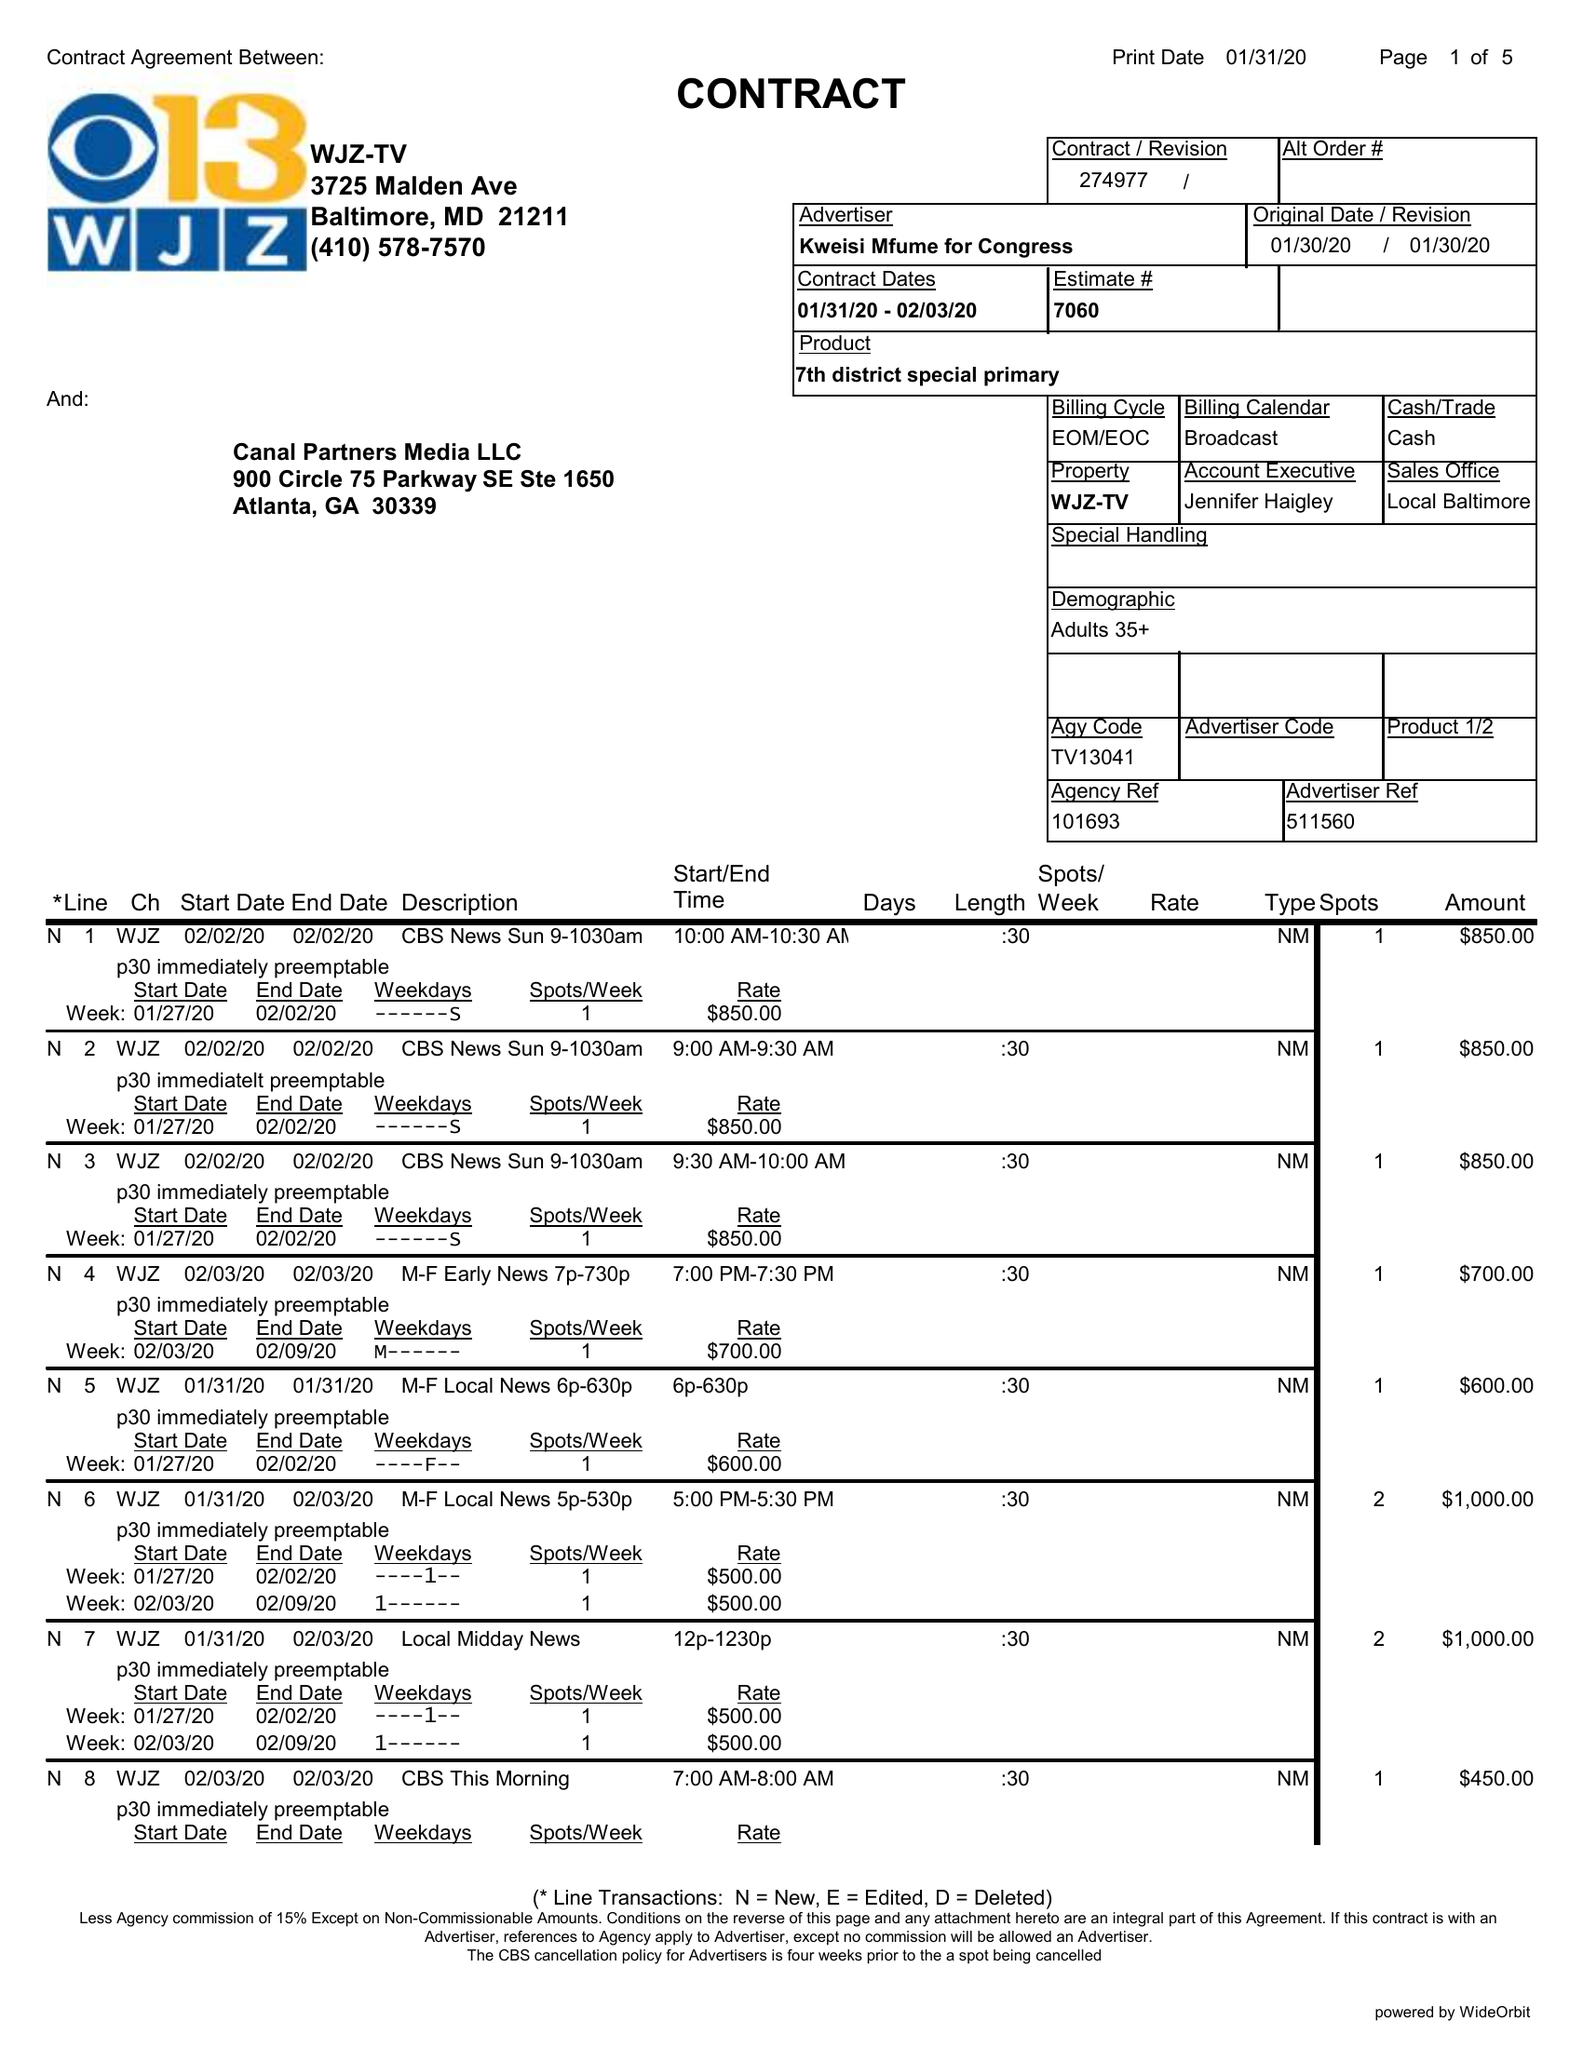What is the value for the contract_num?
Answer the question using a single word or phrase. 274977 